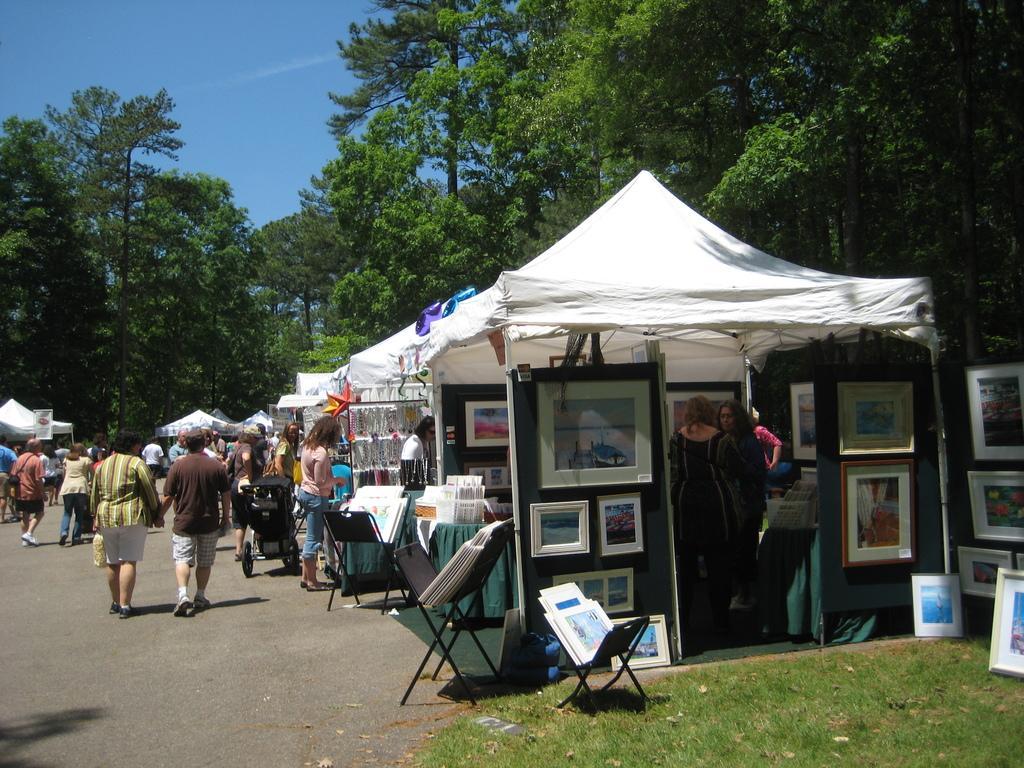In one or two sentences, can you explain what this image depicts? In this image I can see there are few stalls placed on the right side and there are few photo frames, jewelry and a few other stalls, there are people walking on the left side and in the background there are trees and the sky is clear. 